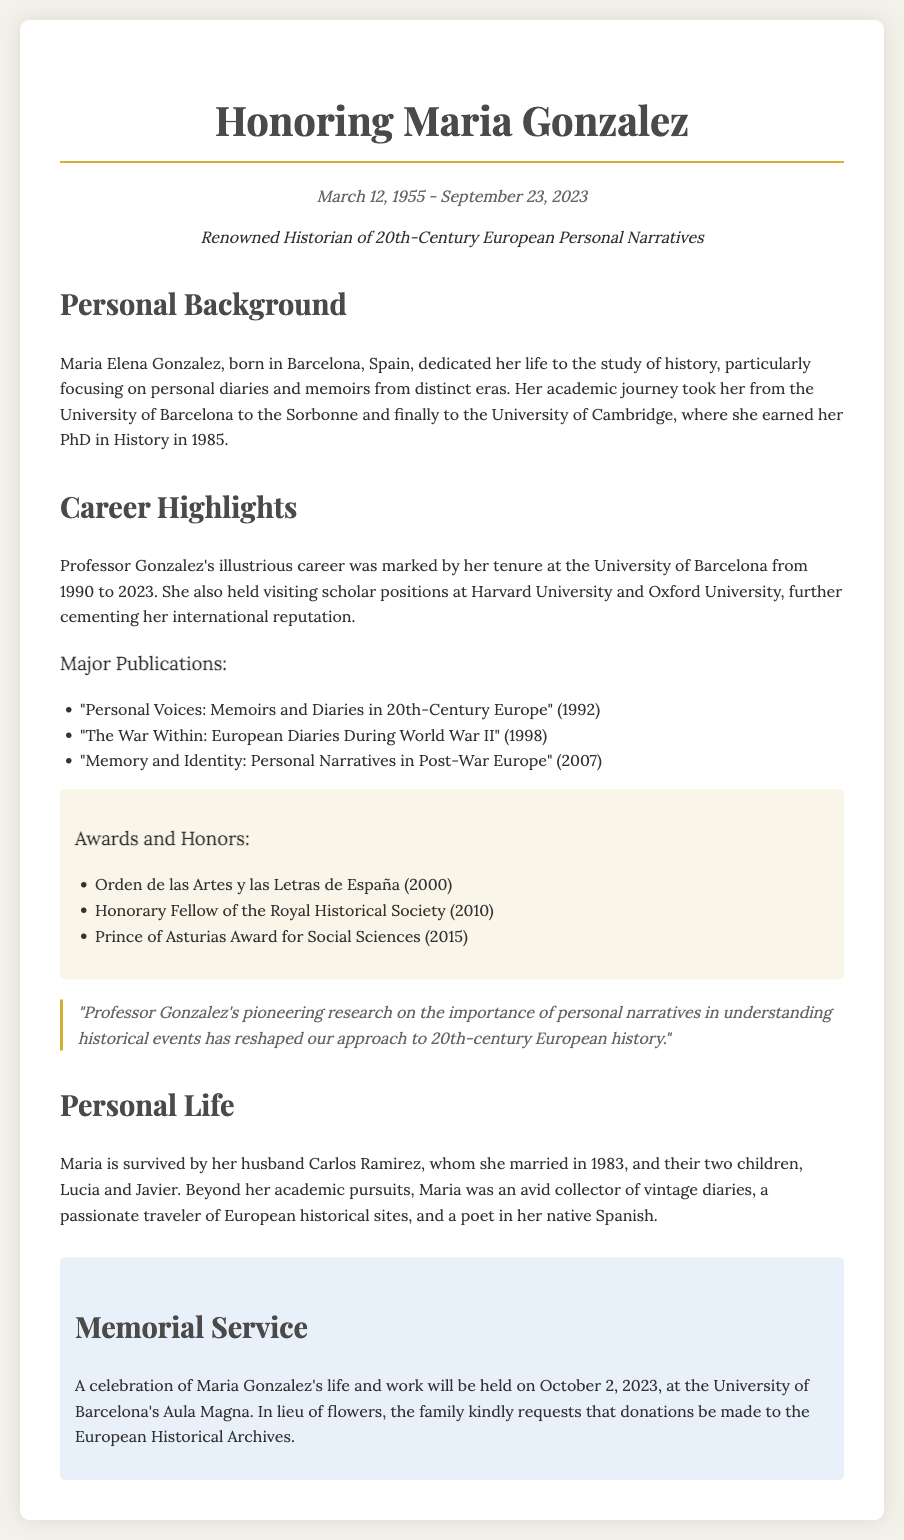What was the date of Maria Gonzalez's birth? The birth date is stated in the document as March 12, 1955.
Answer: March 12, 1955 Where did Maria Gonzalez earn her PhD? The document states that she earned her PhD at the University of Cambridge.
Answer: University of Cambridge Which award did Professor Gonzalez receive in 2015? This question requires identifying a specific honor and the document lists the Prince of Asturias Award for Social Sciences for that year.
Answer: Prince of Asturias Award for Social Sciences What is the name of Maria Gonzalez's husband? The document mentions her husband’s name as Carlos Ramirez.
Answer: Carlos Ramirez What major publication did Maria release in 2007? The document cites "Memory and Identity: Personal Narratives in Post-War Europe" as a 2007 publication.
Answer: Memory and Identity: Personal Narratives in Post-War Europe How many children did Maria Gonzalez have? The document indicates she had two children, Lucia and Javier.
Answer: Two What date is the memorial service for Maria Gonzalez? The memorial service date is stated as October 2, 2023.
Answer: October 2, 2023 What was one of Maria's passions outside of academia? The document notes that she was an avid collector of vintage diaries.
Answer: Vintage diaries 